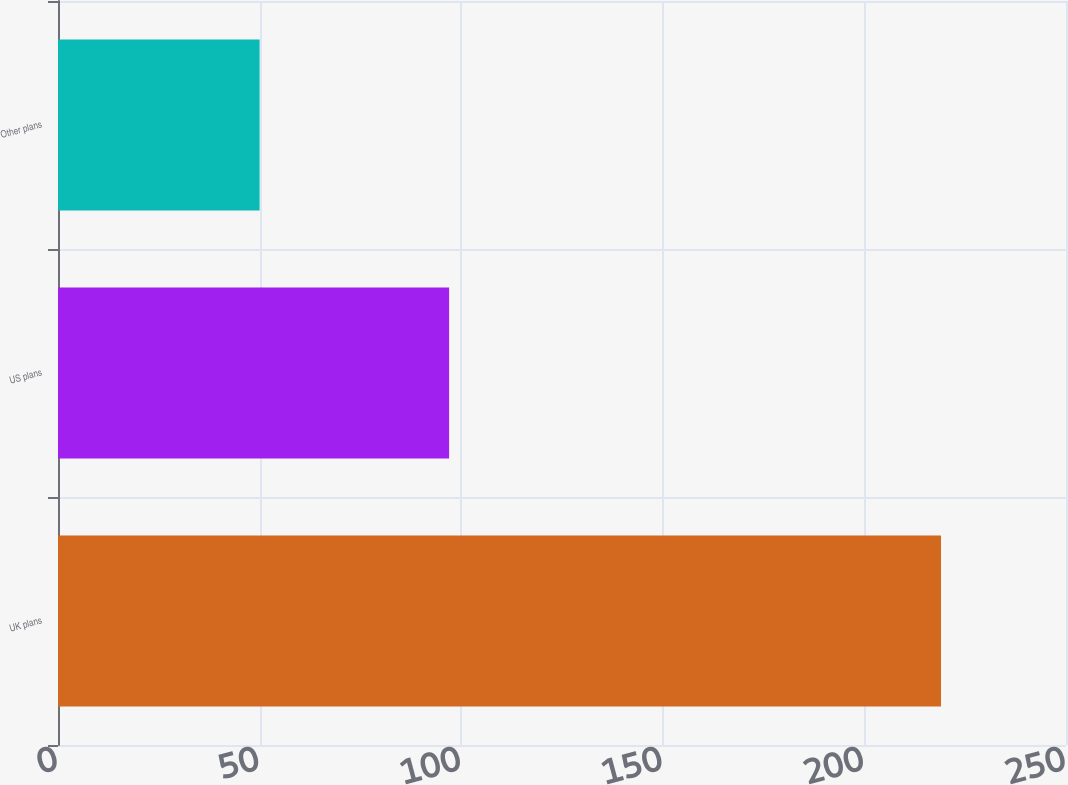<chart> <loc_0><loc_0><loc_500><loc_500><bar_chart><fcel>UK plans<fcel>US plans<fcel>Other plans<nl><fcel>219<fcel>97<fcel>50<nl></chart> 